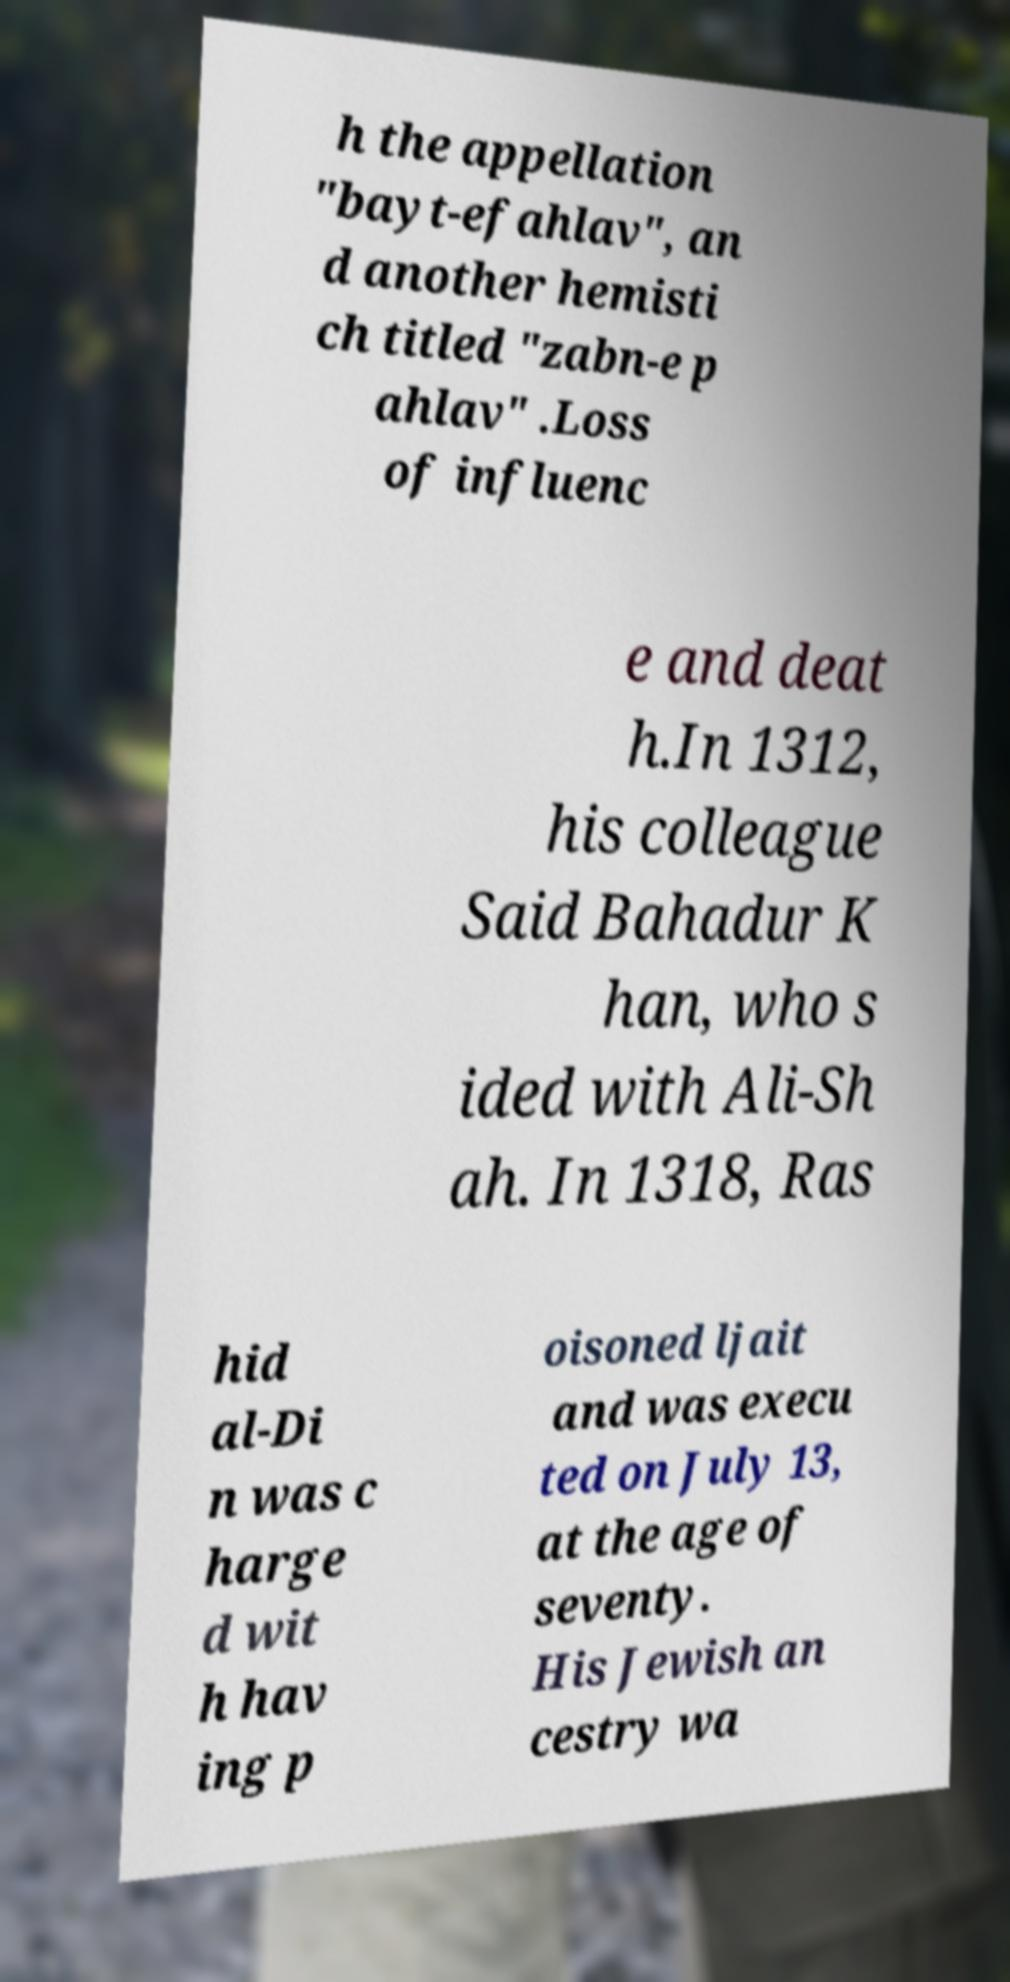Can you accurately transcribe the text from the provided image for me? h the appellation "bayt-efahlav", an d another hemisti ch titled "zabn-e p ahlav" .Loss of influenc e and deat h.In 1312, his colleague Said Bahadur K han, who s ided with Ali-Sh ah. In 1318, Ras hid al-Di n was c harge d wit h hav ing p oisoned ljait and was execu ted on July 13, at the age of seventy. His Jewish an cestry wa 